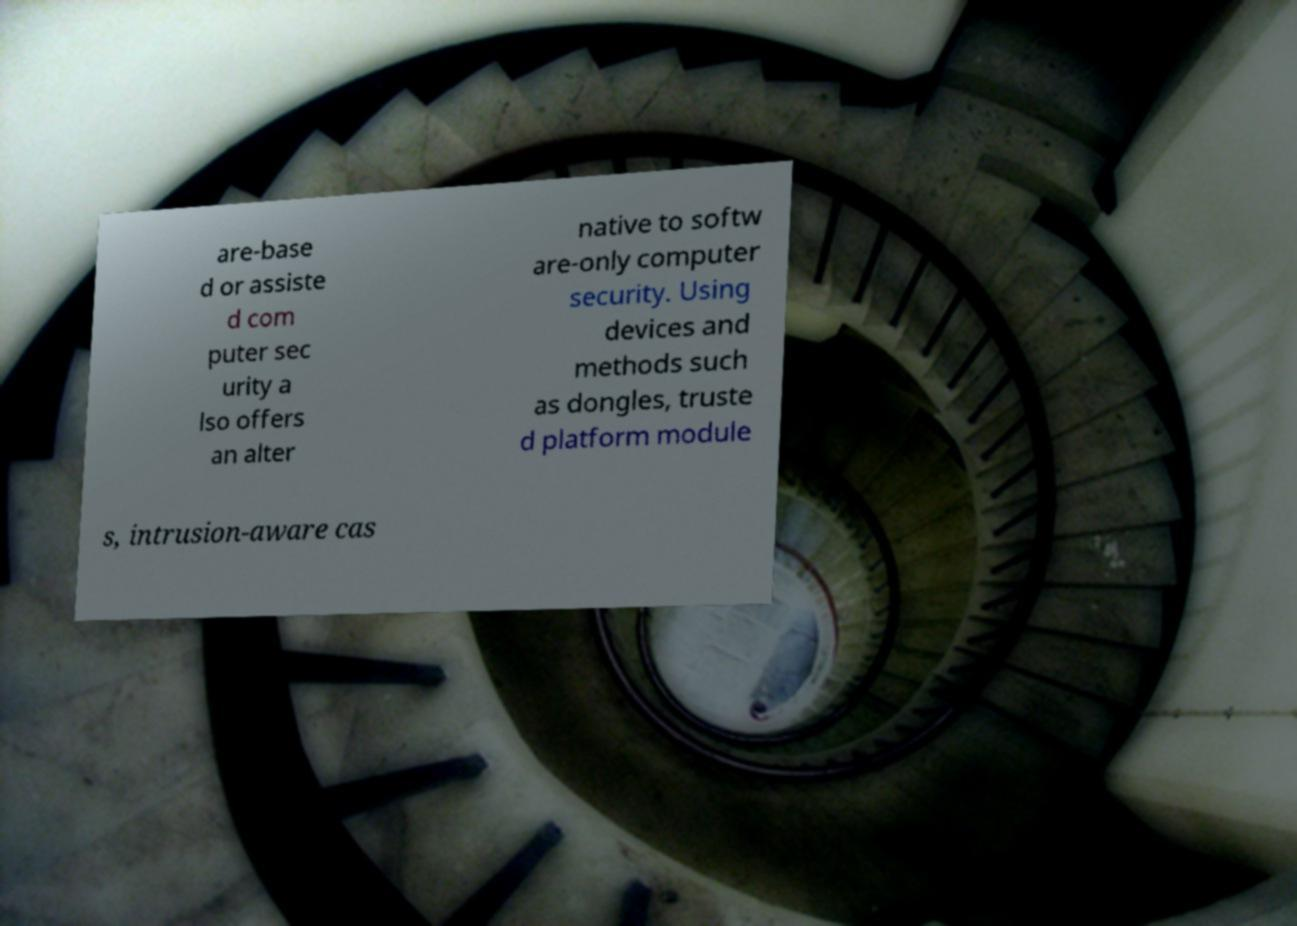Can you accurately transcribe the text from the provided image for me? are-base d or assiste d com puter sec urity a lso offers an alter native to softw are-only computer security. Using devices and methods such as dongles, truste d platform module s, intrusion-aware cas 